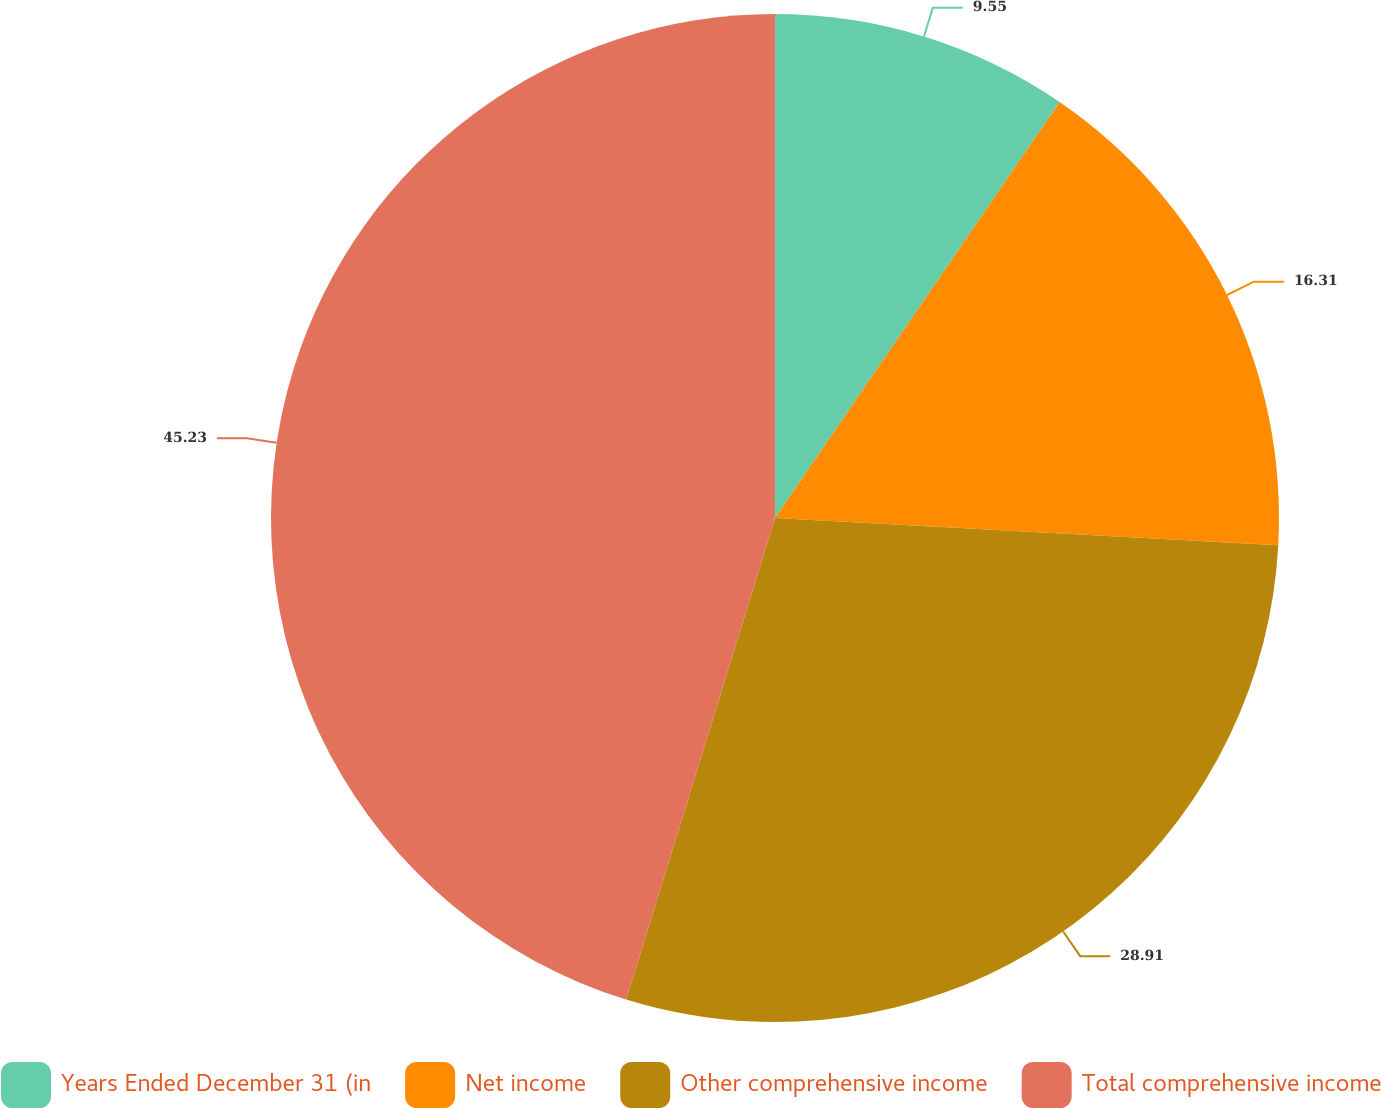Convert chart. <chart><loc_0><loc_0><loc_500><loc_500><pie_chart><fcel>Years Ended December 31 (in<fcel>Net income<fcel>Other comprehensive income<fcel>Total comprehensive income<nl><fcel>9.55%<fcel>16.31%<fcel>28.91%<fcel>45.23%<nl></chart> 